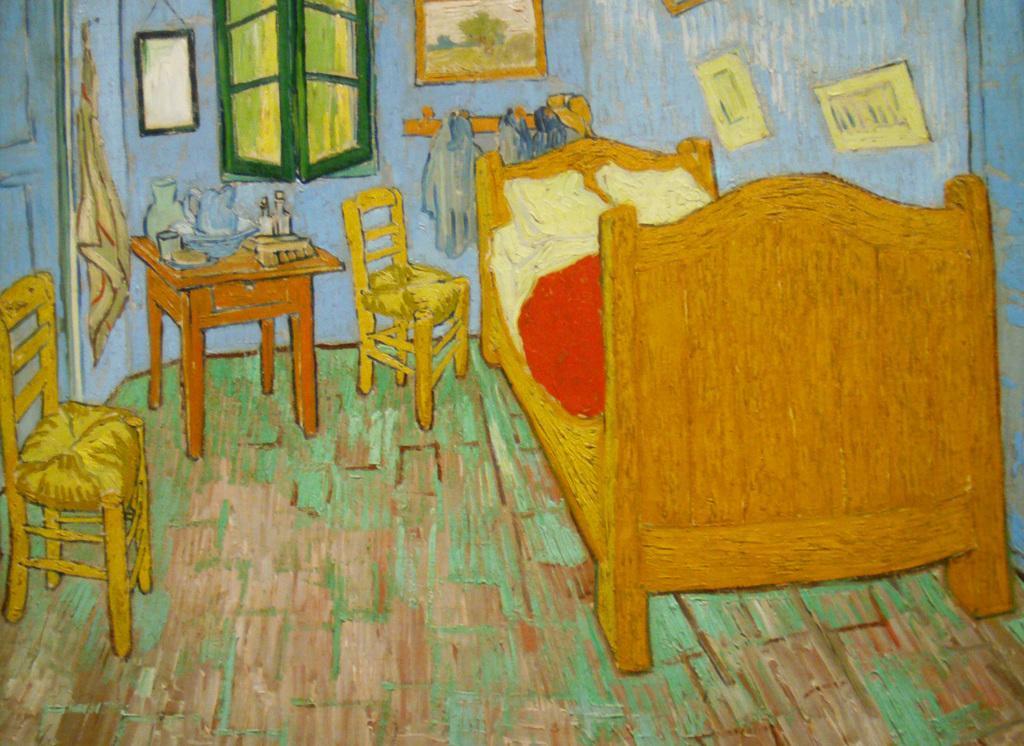Can you describe this image briefly? This is a painting, in this image there is a bed, chairs, tablecloths, window, photo frames, door and wall. At the bottom there is floor. 